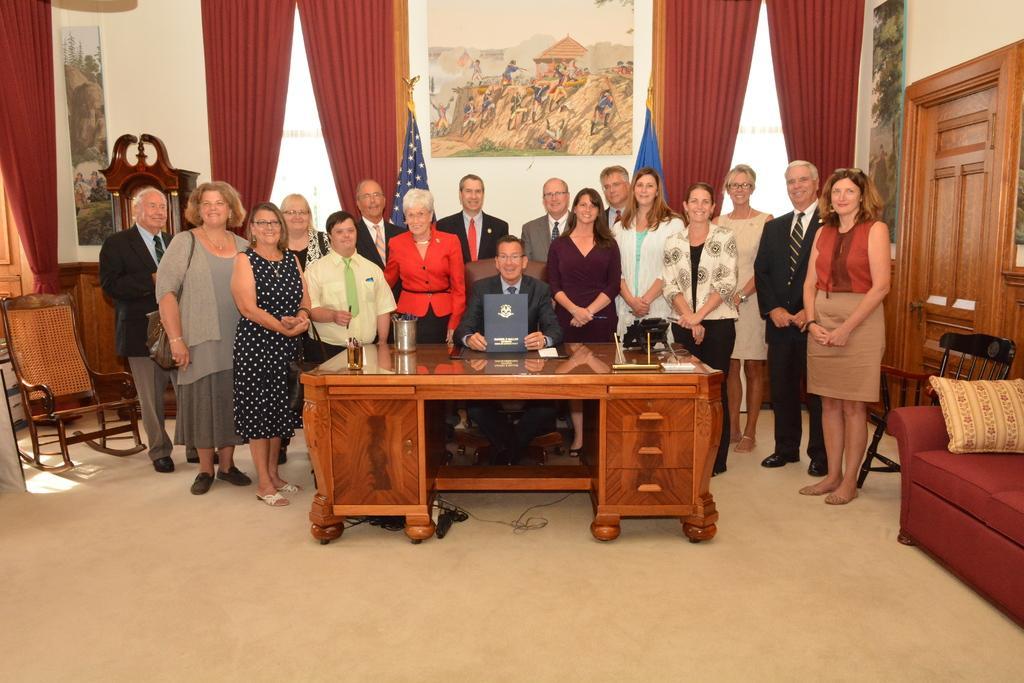How would you summarize this image in a sentence or two? In this picture we can see a group of people standing and in middle man sitting on chair and holding book in his hand and on table we can see pen stand, bottle and in background we can see a curtains, frames, flags, pillow, chair. 